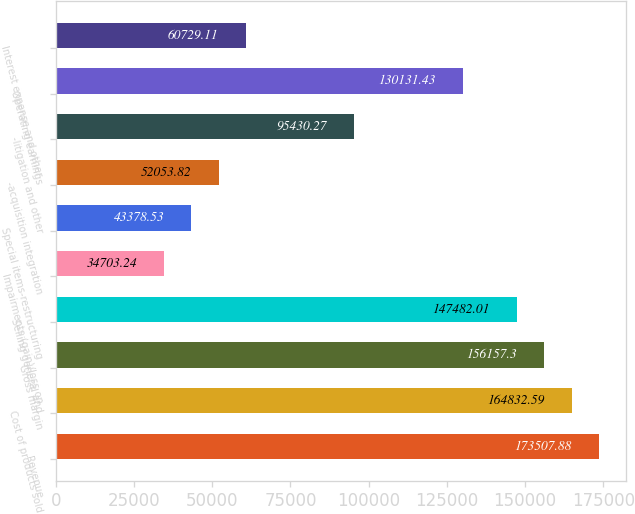<chart> <loc_0><loc_0><loc_500><loc_500><bar_chart><fcel>Revenue<fcel>Cost of products sold<fcel>Gross margin<fcel>Selling general and<fcel>Impairments (gain)/loss on<fcel>Special items-restructuring<fcel>-acquisition integration<fcel>-litigation and other<fcel>Operating earnings<fcel>Interest expense and other<nl><fcel>173508<fcel>164833<fcel>156157<fcel>147482<fcel>34703.2<fcel>43378.5<fcel>52053.8<fcel>95430.3<fcel>130131<fcel>60729.1<nl></chart> 